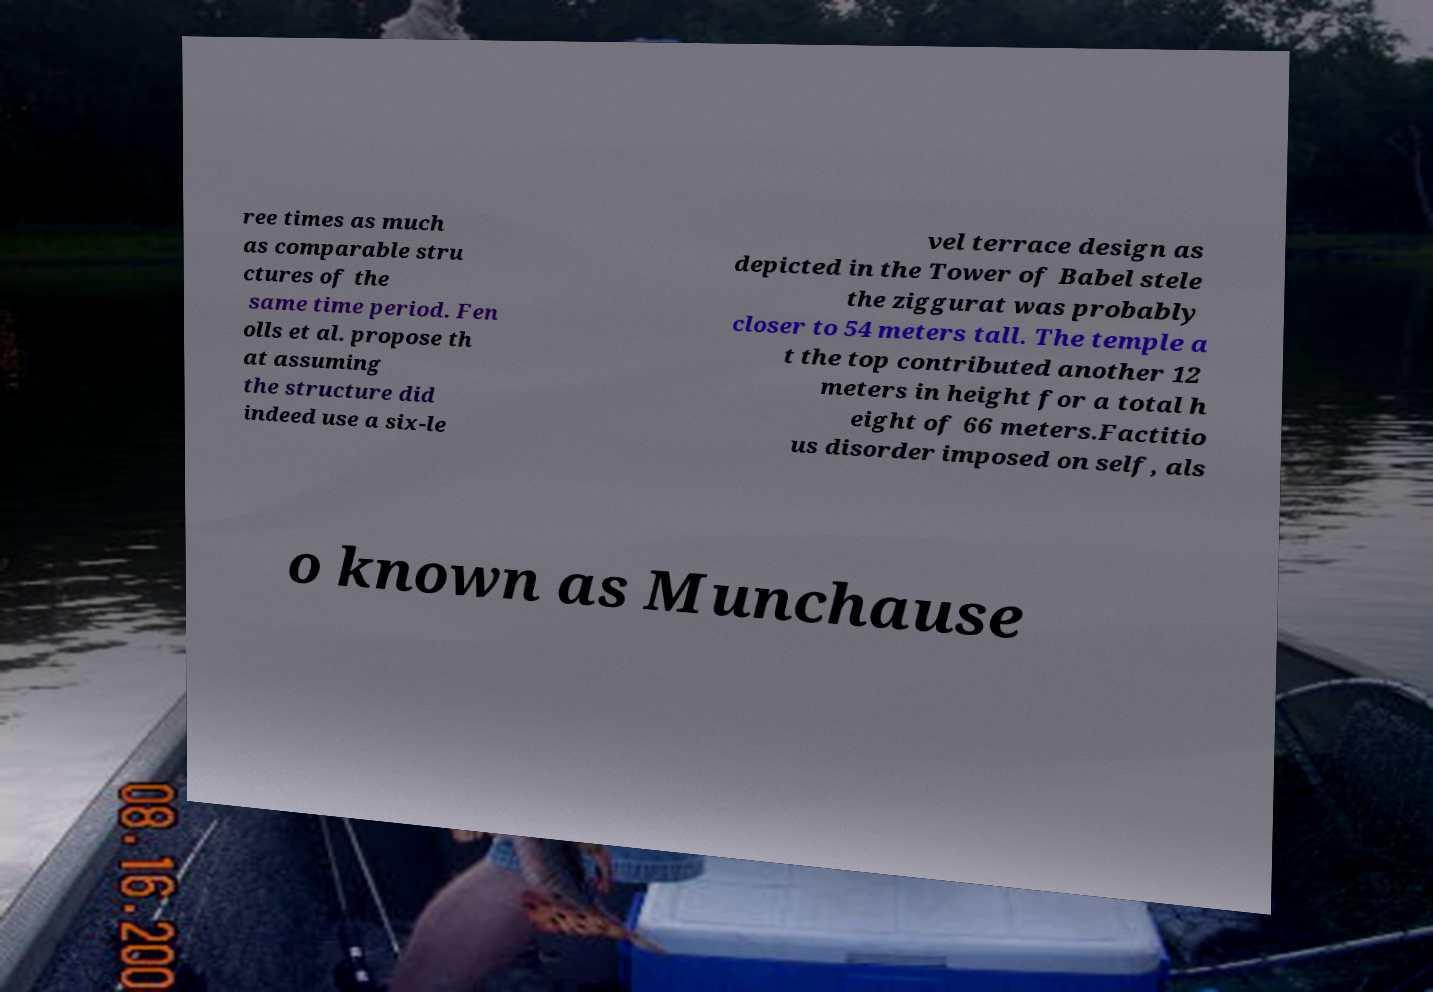Could you extract and type out the text from this image? ree times as much as comparable stru ctures of the same time period. Fen olls et al. propose th at assuming the structure did indeed use a six-le vel terrace design as depicted in the Tower of Babel stele the ziggurat was probably closer to 54 meters tall. The temple a t the top contributed another 12 meters in height for a total h eight of 66 meters.Factitio us disorder imposed on self, als o known as Munchause 